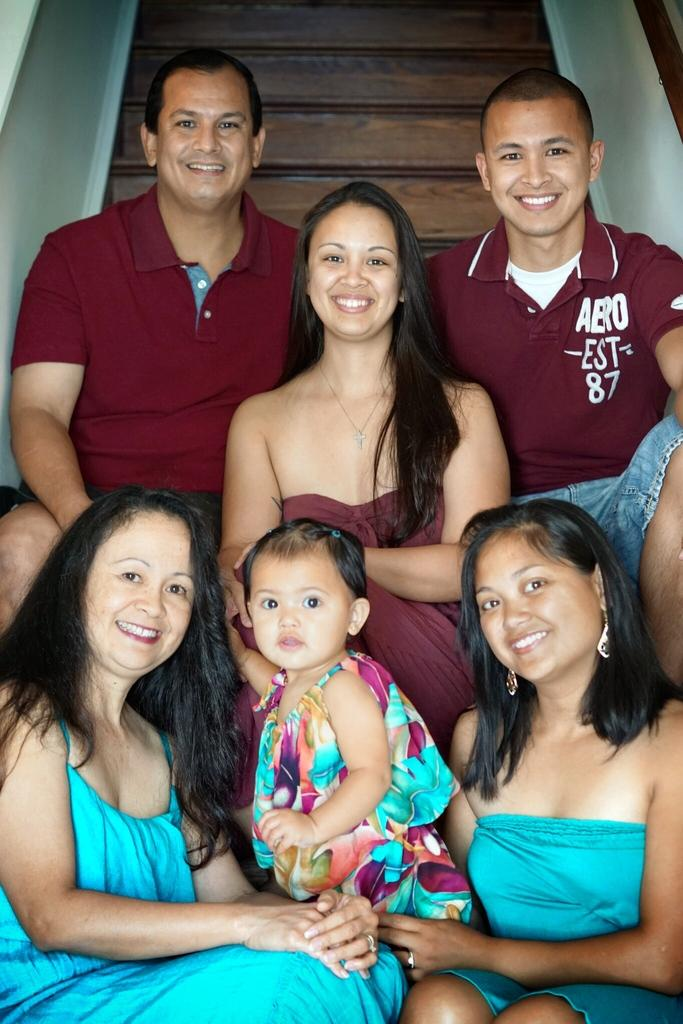What is the main subject of the image? The main subject of the image is a group of people. How are the people dressed in the image? The people are wearing different color dresses in the image. What is the facial expression of the people in the image? The people are smiling in the image. What can be seen in the background of the image? There are stairs and railing visible in the background of the image. What type of friction can be seen between the people in the image? There is no friction visible between the people in the image; they are simply standing together and smiling. Can you tell me how many balloons are being held by the people in the image? There are no balloons present in the image; the people are not holding any balloons. 